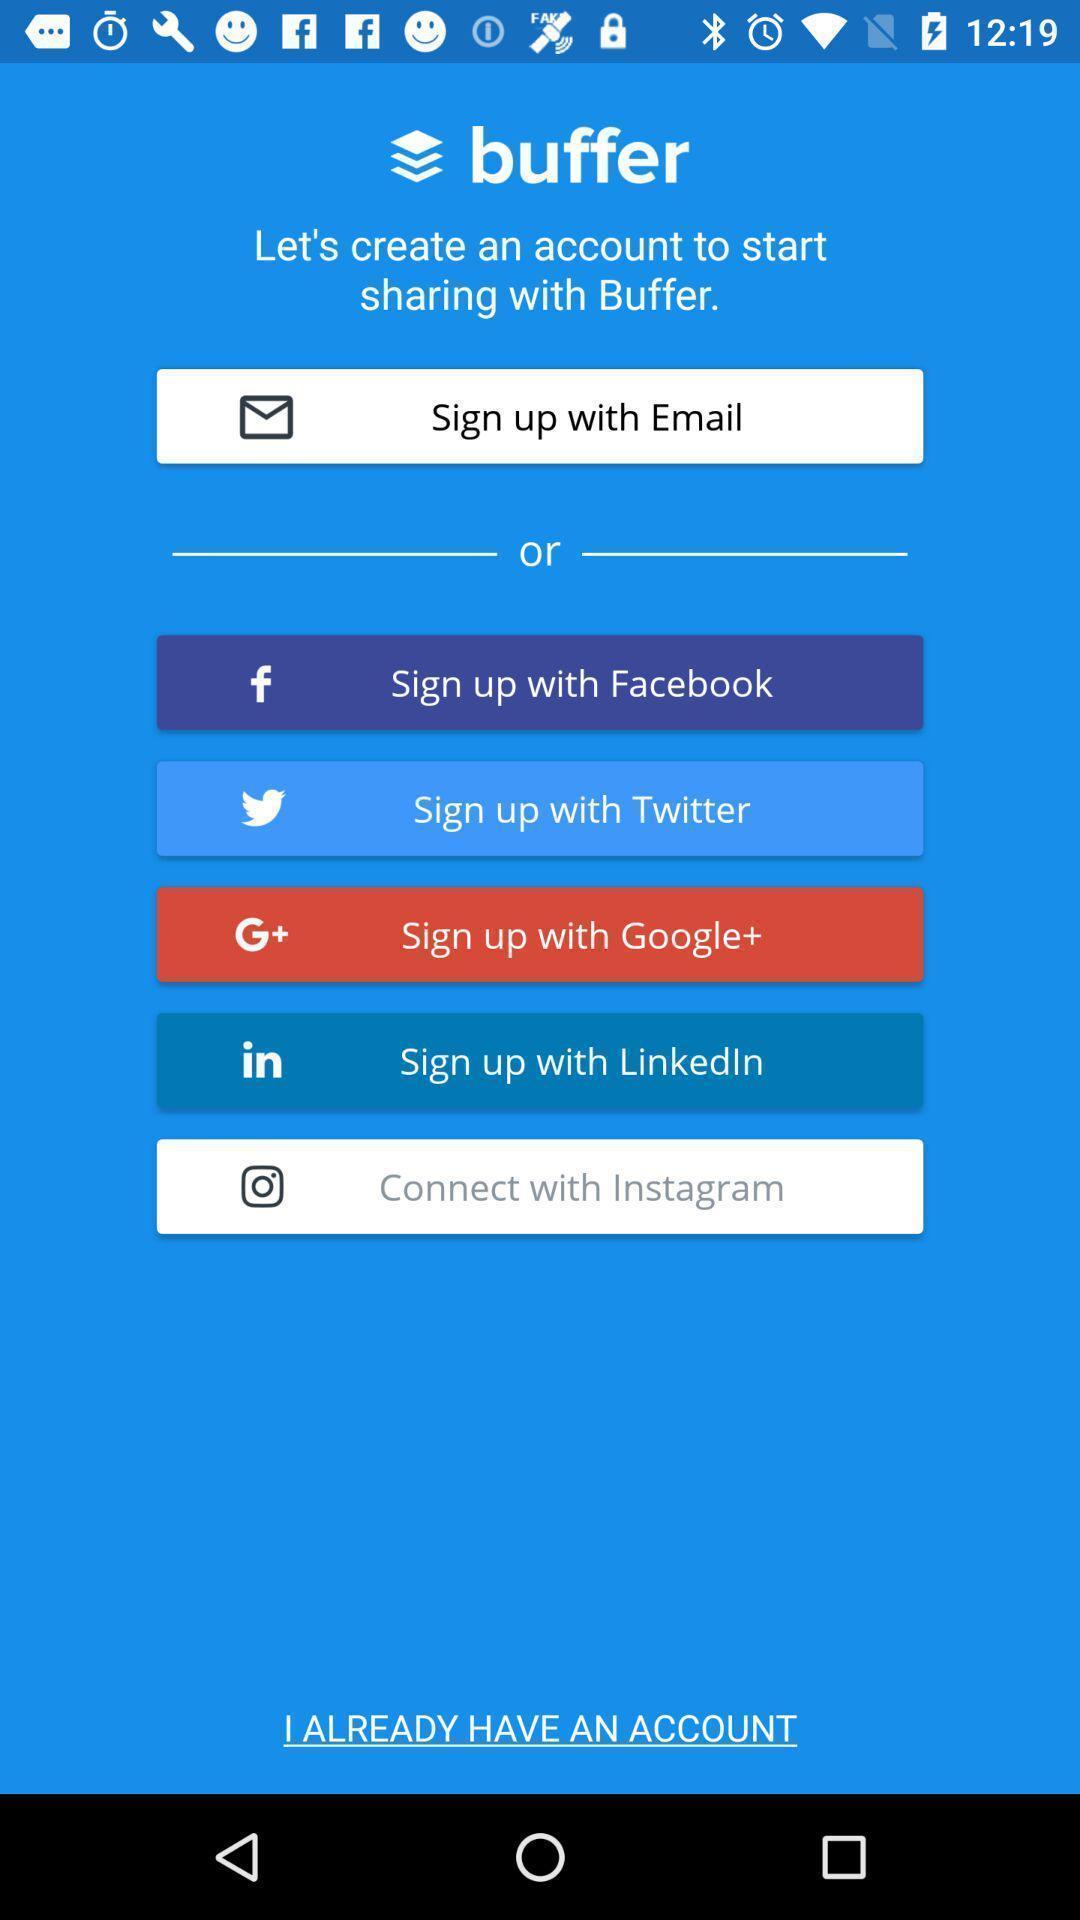Describe the visual elements of this screenshot. Sign up page. 